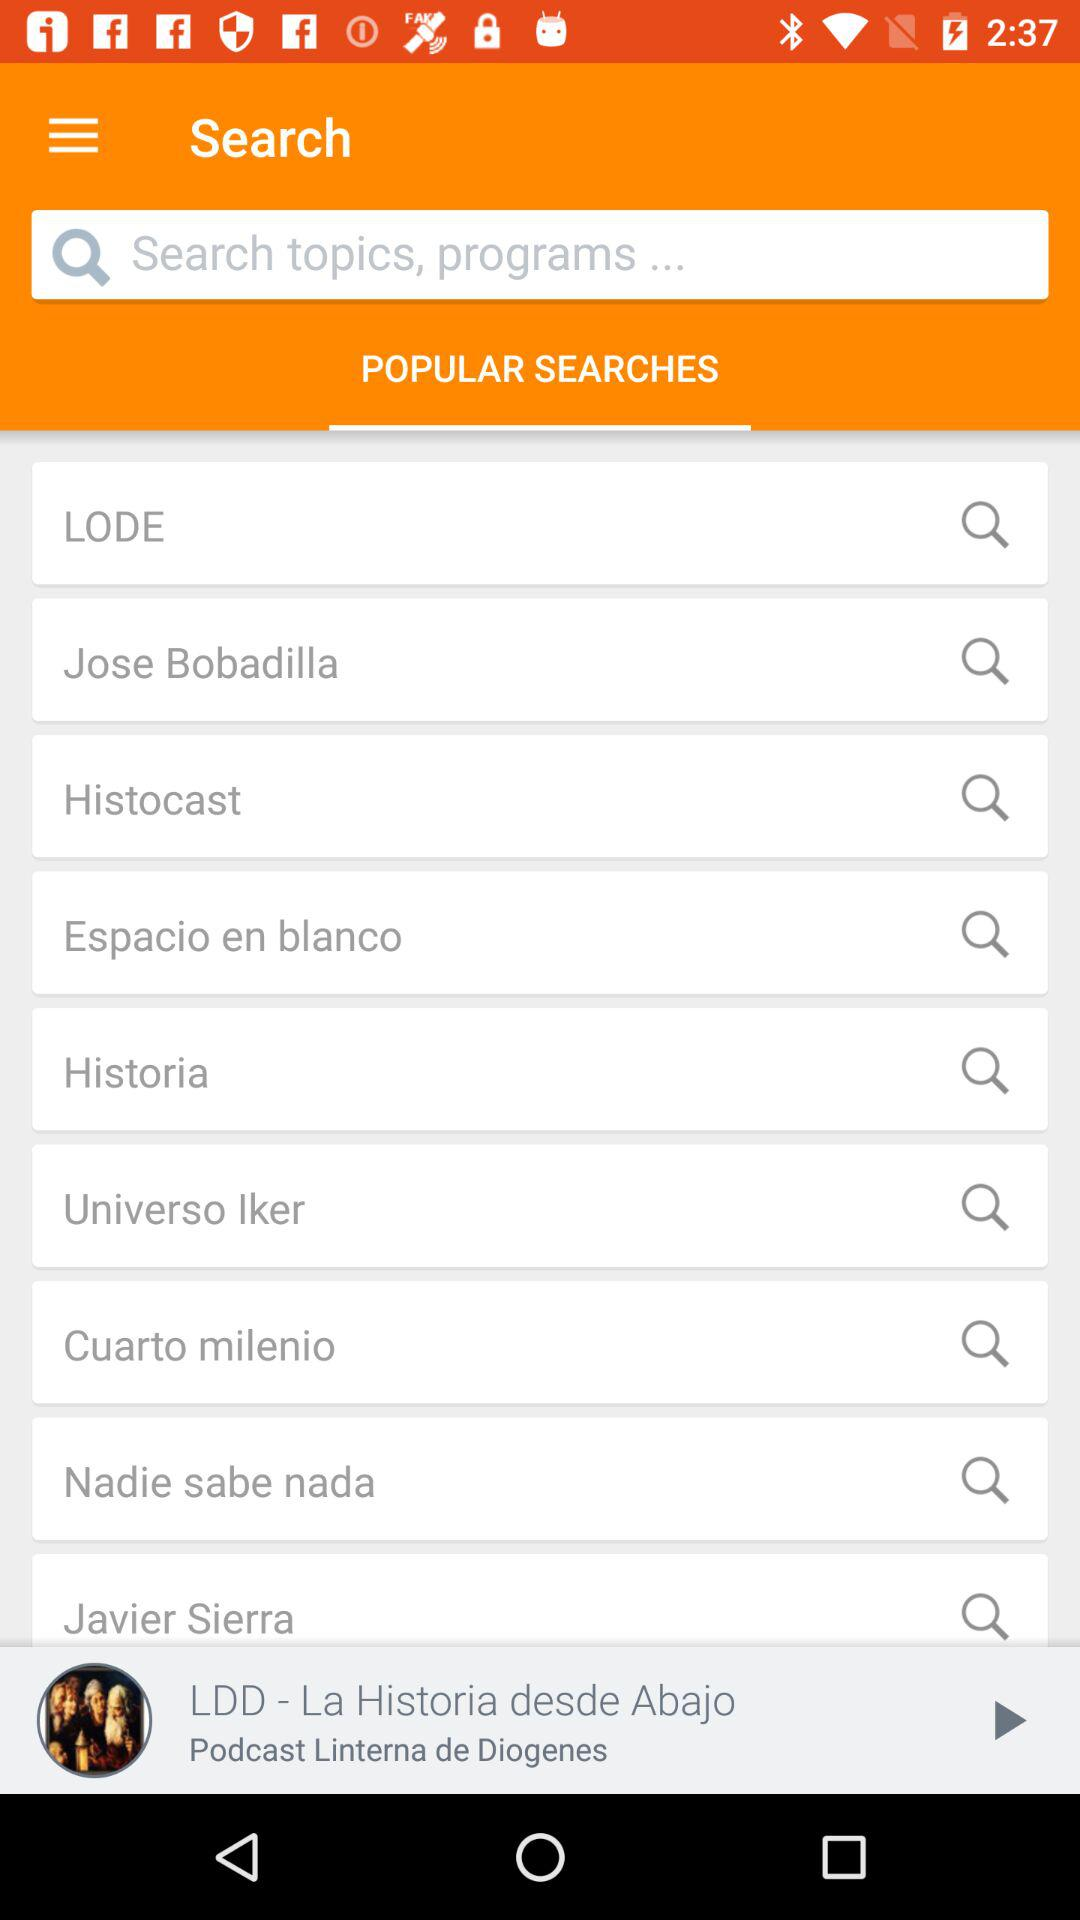What is the name of the podcast that was last played? The name of the podcast that was last played is "LDD - La Historia desde Abajo". 